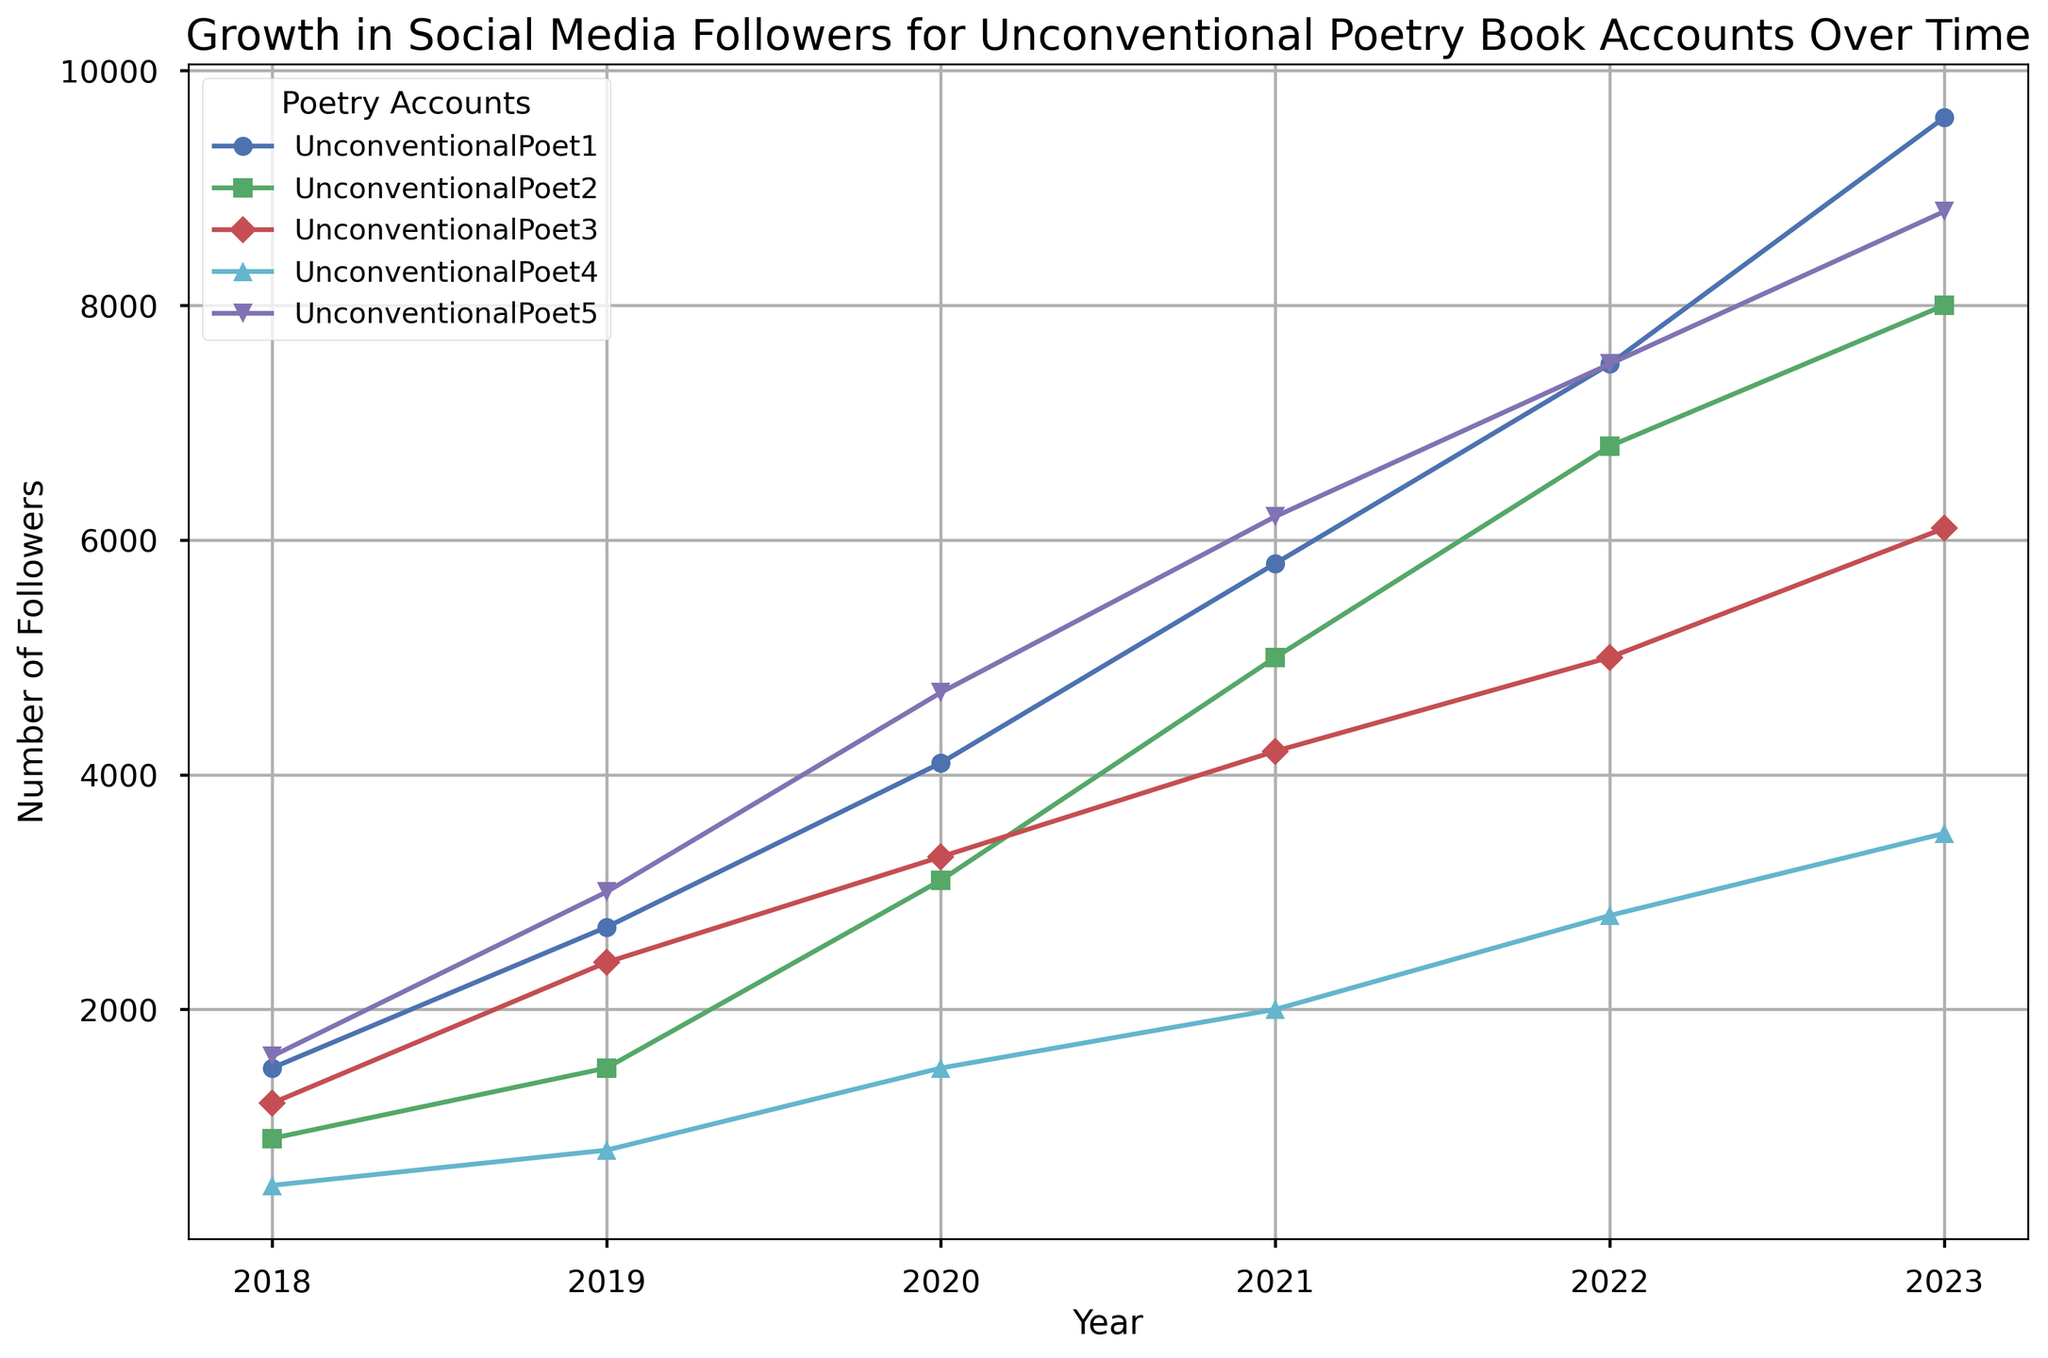Which account had the highest number of followers in 2023? To find this, we look at the end of the lines for the year 2023. UnconventionalPoet1 has the highest number of followers in 2023, with 9600 followers.
Answer: UnconventionalPoet1 How many followers did UnconventionalPoet2 gain between 2018 and 2023? We subtract the number of followers in 2018 (900) from the number of followers in 2023 (8000). So, 8000 - 900 = 7100.
Answer: 7100 Which account experienced the largest growth in followers from 2018 to 2023? To determine this, we find the difference between the followers in 2018 and 2023 for each account. UnconventionalPoet1: 9600 - 1500 = 8100, UnconventionalPoet2: 8000 - 900 = 7100, UnconventionalPoet3: 6100 - 1200 = 4900, UnconventionalPoet4: 3500 - 500 = 3000, UnconventionalPoet5: 8800 - 1600 = 7200. UnconventionalPoet1 experienced the largest growth.
Answer: UnconventionalPoet1 What is the average number of followers for UnconventionalPoet3 from 2018 to 2023? The average is calculated by summing the followers for each year and then dividing by the number of years: (1200 + 2400 + 3300 + 4200 + 5000 + 6100) / 6 = 22000 / 6 = 3666.67.
Answer: 3666.67 Which two accounts had the closest number of followers in 2022? By examining the data for 2022, we see UnconventionalPoet1 had 7500, UnconventionalPoet2 had 6800, UnconventionalPoet3 had 5000, UnconventionalPoet4 had 2800, and UnconventionalPoet5 had 7500. UnconventionalPoet1 and UnconventionalPoet5 both had 7500 followers, which is the closest match.
Answer: UnconventionalPoet1 and UnconventionalPoet5 In which year did UnconventionalPoet4 reach 1500 followers? We inspect the data and notice that UnconventionalPoet4 had exactly 1500 followers in the year 2020.
Answer: 2020 What is the total combined number of followers for all accounts in 2023? We sum the followers for all accounts in 2023: 9600 + 8000 + 6100 + 3500 + 8800 = 36000.
Answer: 36000 Did any account have a decline in followers between any two consecutive years? The chart shows that all accounts have a steady increase in followers every year, and no account faced a decline between any two consecutive years.
Answer: No Which account had the least growth in followers from 2018 to 2023? To find this, we calculate the difference in followers between 2018 and 2023 for each account: UnconventionalPoet1: 8100, UnconventionalPoet2: 7100, UnconventionalPoet3: 4900, UnconventionalPoet4: 3000, UnconventionalPoet5: 7200. UnconventionalPoet4 had the least growth.
Answer: UnconventionalPoet4 How did the follower growth trend for UnconventionalPoet5 compare to UnconventionalPoet3 from 2018 to 2023? We can see that UnconventionalPoet5's growth trend shows a steeper increase compared to UnconventionalPoet3. Starting from a higher number of followers in 2018 (1600 vs 1200), UnconventionalPoet5 ended up with significantly more followers in 2023 (8800 vs 6100).
Answer: Steeper growth 